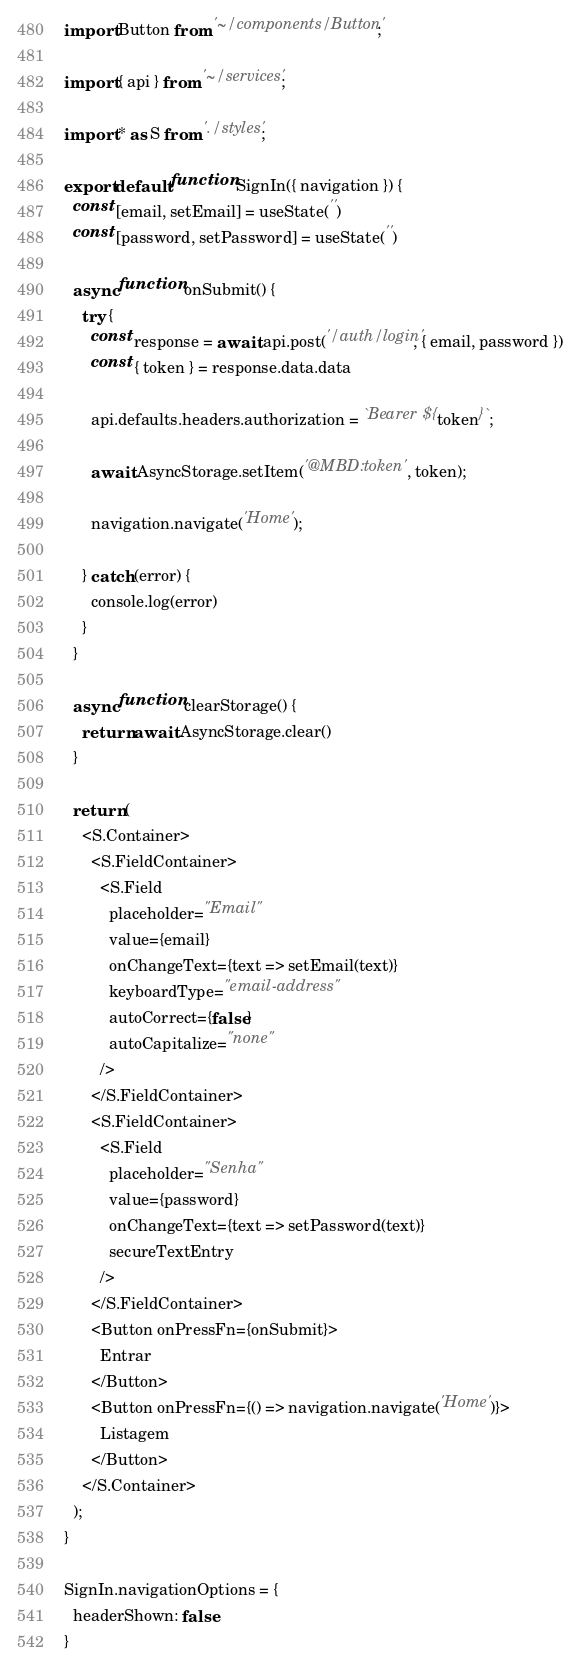Convert code to text. <code><loc_0><loc_0><loc_500><loc_500><_JavaScript_>import Button from '~/components/Button';

import { api } from '~/services';

import * as S from './styles';

export default function SignIn({ navigation }) {
  const [email, setEmail] = useState('')
  const [password, setPassword] = useState('')

  async function onSubmit() {
    try {
      const response = await api.post('/auth/login', { email, password })
      const { token } = response.data.data

      api.defaults.headers.authorization = `Bearer ${token}`;

      await AsyncStorage.setItem('@MBD:token', token);

      navigation.navigate('Home');

    } catch (error) {
      console.log(error)
    }
  }

  async function clearStorage() {
    return await AsyncStorage.clear()
  }

  return (
    <S.Container>
      <S.FieldContainer>
        <S.Field
          placeholder="Email"
          value={email}
          onChangeText={text => setEmail(text)}
          keyboardType="email-address"
          autoCorrect={false}
          autoCapitalize="none"
        />
      </S.FieldContainer>
      <S.FieldContainer>
        <S.Field
          placeholder="Senha"
          value={password}
          onChangeText={text => setPassword(text)}
          secureTextEntry
        />
      </S.FieldContainer>
      <Button onPressFn={onSubmit}>
        Entrar
      </Button>
      <Button onPressFn={() => navigation.navigate('Home')}>
        Listagem
      </Button>
    </S.Container>
  );
}

SignIn.navigationOptions = {
  headerShown: false
}
</code> 